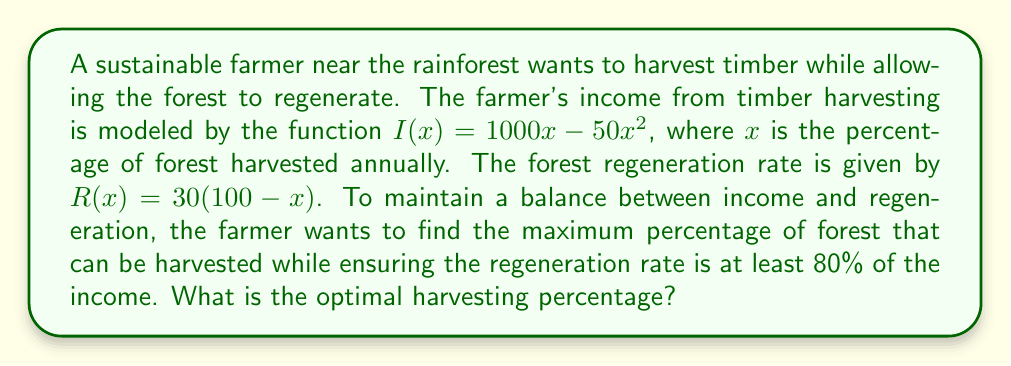Show me your answer to this math problem. 1) First, we need to set up an inequality to represent the constraint:
   $R(x) \geq 0.8I(x)$

2) Substitute the given functions:
   $30(100-x) \geq 0.8(1000x - 50x^2)$

3) Expand the brackets:
   $3000 - 30x \geq 800x - 40x^2$

4) Rearrange the terms to standard quadratic form:
   $40x^2 - 830x + 3000 \geq 0$

5) Solve this quadratic inequality:
   a) Find the roots of the quadratic equation $40x^2 - 830x + 3000 = 0$
   b) Use the quadratic formula: $x = \frac{-b \pm \sqrt{b^2 - 4ac}}{2a}$
   c) $x = \frac{830 \pm \sqrt{830^2 - 4(40)(3000)}}{2(40)}$
   d) $x \approx 3.75$ or $x \approx 20$

6) The inequality is satisfied when $x \leq 3.75$ or $x \geq 20$

7) Since $x$ represents a percentage, it must be between 0 and 100.
   Also, we want to maximize $x$ while satisfying the constraint.

8) Therefore, the optimal harvesting percentage is 3.75%.
Answer: 3.75% 